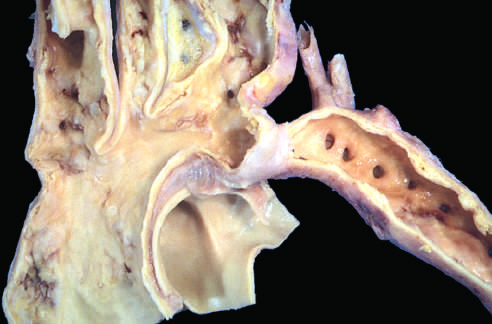what is a segmental narrowing of the aorta?
Answer the question using a single word or phrase. Coarctation 